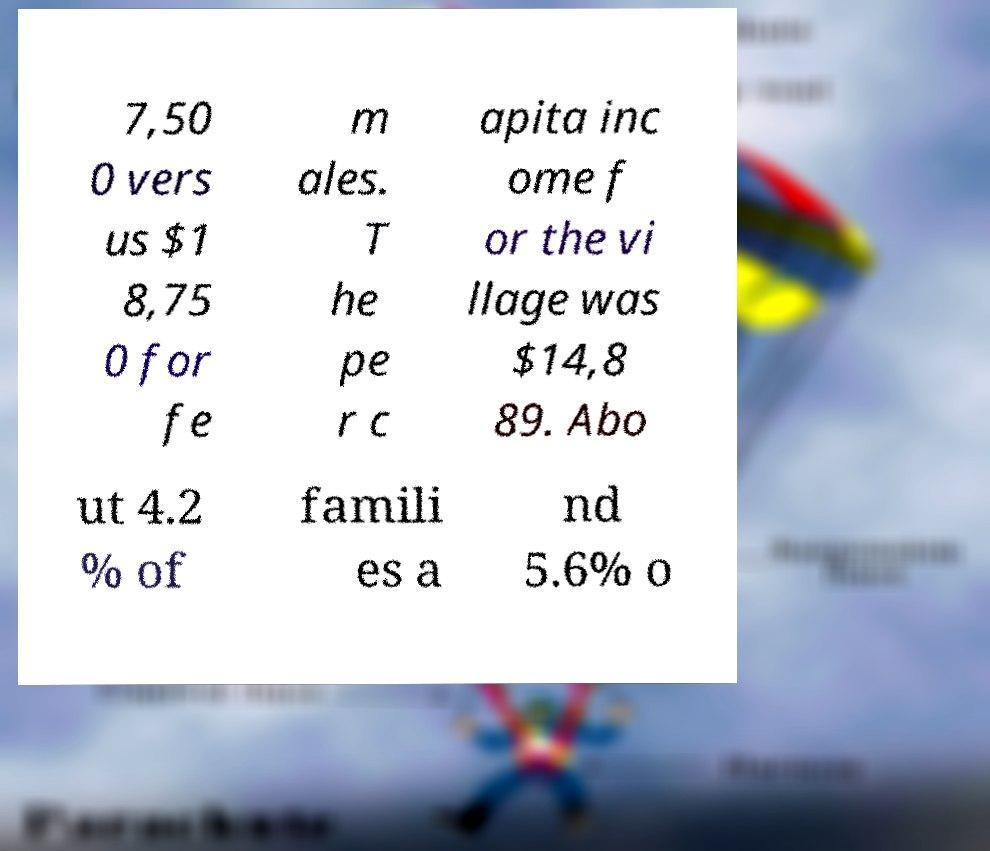Can you read and provide the text displayed in the image?This photo seems to have some interesting text. Can you extract and type it out for me? 7,50 0 vers us $1 8,75 0 for fe m ales. T he pe r c apita inc ome f or the vi llage was $14,8 89. Abo ut 4.2 % of famili es a nd 5.6% o 